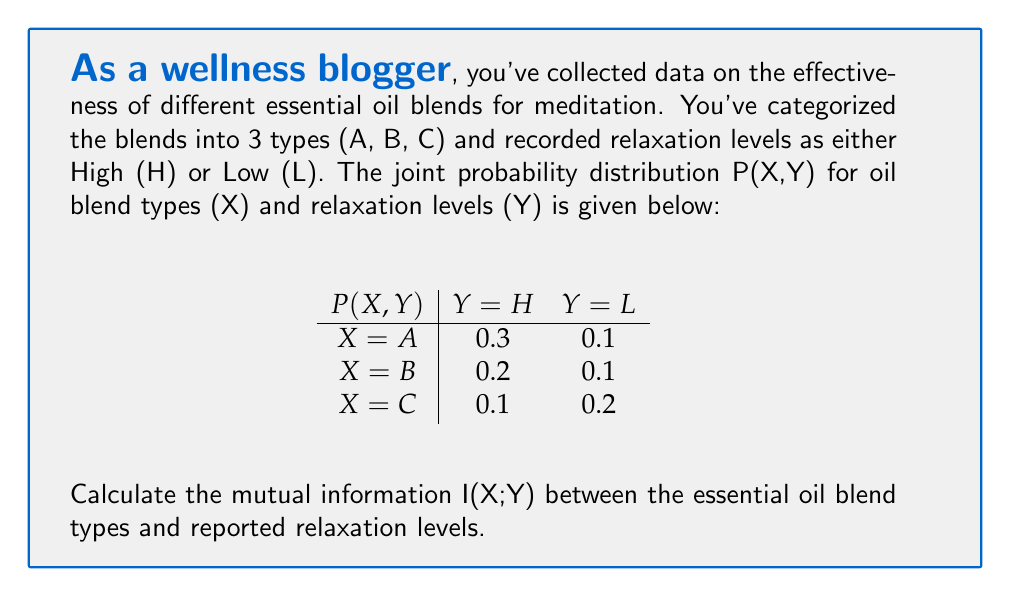Show me your answer to this math problem. To calculate the mutual information I(X;Y), we'll follow these steps:

1) First, we need to calculate the marginal probabilities P(X) and P(Y):

   P(X=A) = 0.3 + 0.1 = 0.4
   P(X=B) = 0.2 + 0.1 = 0.3
   P(X=C) = 0.1 + 0.2 = 0.3
   P(Y=H) = 0.3 + 0.2 + 0.1 = 0.6
   P(Y=L) = 0.1 + 0.1 + 0.2 = 0.4

2) The mutual information is defined as:

   $$I(X;Y) = \sum_{x,y} P(x,y) \log_2 \frac{P(x,y)}{P(x)P(y)}$$

3) Let's calculate each term:

   For X=A, Y=H: $0.3 \log_2 \frac{0.3}{0.4 \cdot 0.6} = 0.3 \log_2 1.25 = 0.3 \cdot 0.3219 = 0.0966$
   For X=A, Y=L: $0.1 \log_2 \frac{0.1}{0.4 \cdot 0.4} = 0.1 \log_2 0.625 = 0.1 \cdot (-0.6781) = -0.0678$
   For X=B, Y=H: $0.2 \log_2 \frac{0.2}{0.3 \cdot 0.6} = 0.2 \log_2 1.1111 = 0.2 \cdot 0.1520 = 0.0304$
   For X=B, Y=L: $0.1 \log_2 \frac{0.1}{0.3 \cdot 0.4} = 0.1 \log_2 0.8333 = 0.1 \cdot (-0.2630) = -0.0263$
   For X=C, Y=H: $0.1 \log_2 \frac{0.1}{0.3 \cdot 0.6} = 0.1 \log_2 0.5556 = 0.1 \cdot (-0.8480) = -0.0848$
   For X=C, Y=L: $0.2 \log_2 \frac{0.2}{0.3 \cdot 0.4} = 0.2 \log_2 1.6667 = 0.2 \cdot 0.7370 = 0.1474$

4) Sum all these terms:

   I(X;Y) = 0.0966 - 0.0678 + 0.0304 - 0.0263 - 0.0848 + 0.1474 = 0.0955 bits
Answer: The mutual information I(X;Y) between essential oil blend types and reported relaxation levels is approximately 0.0955 bits. 